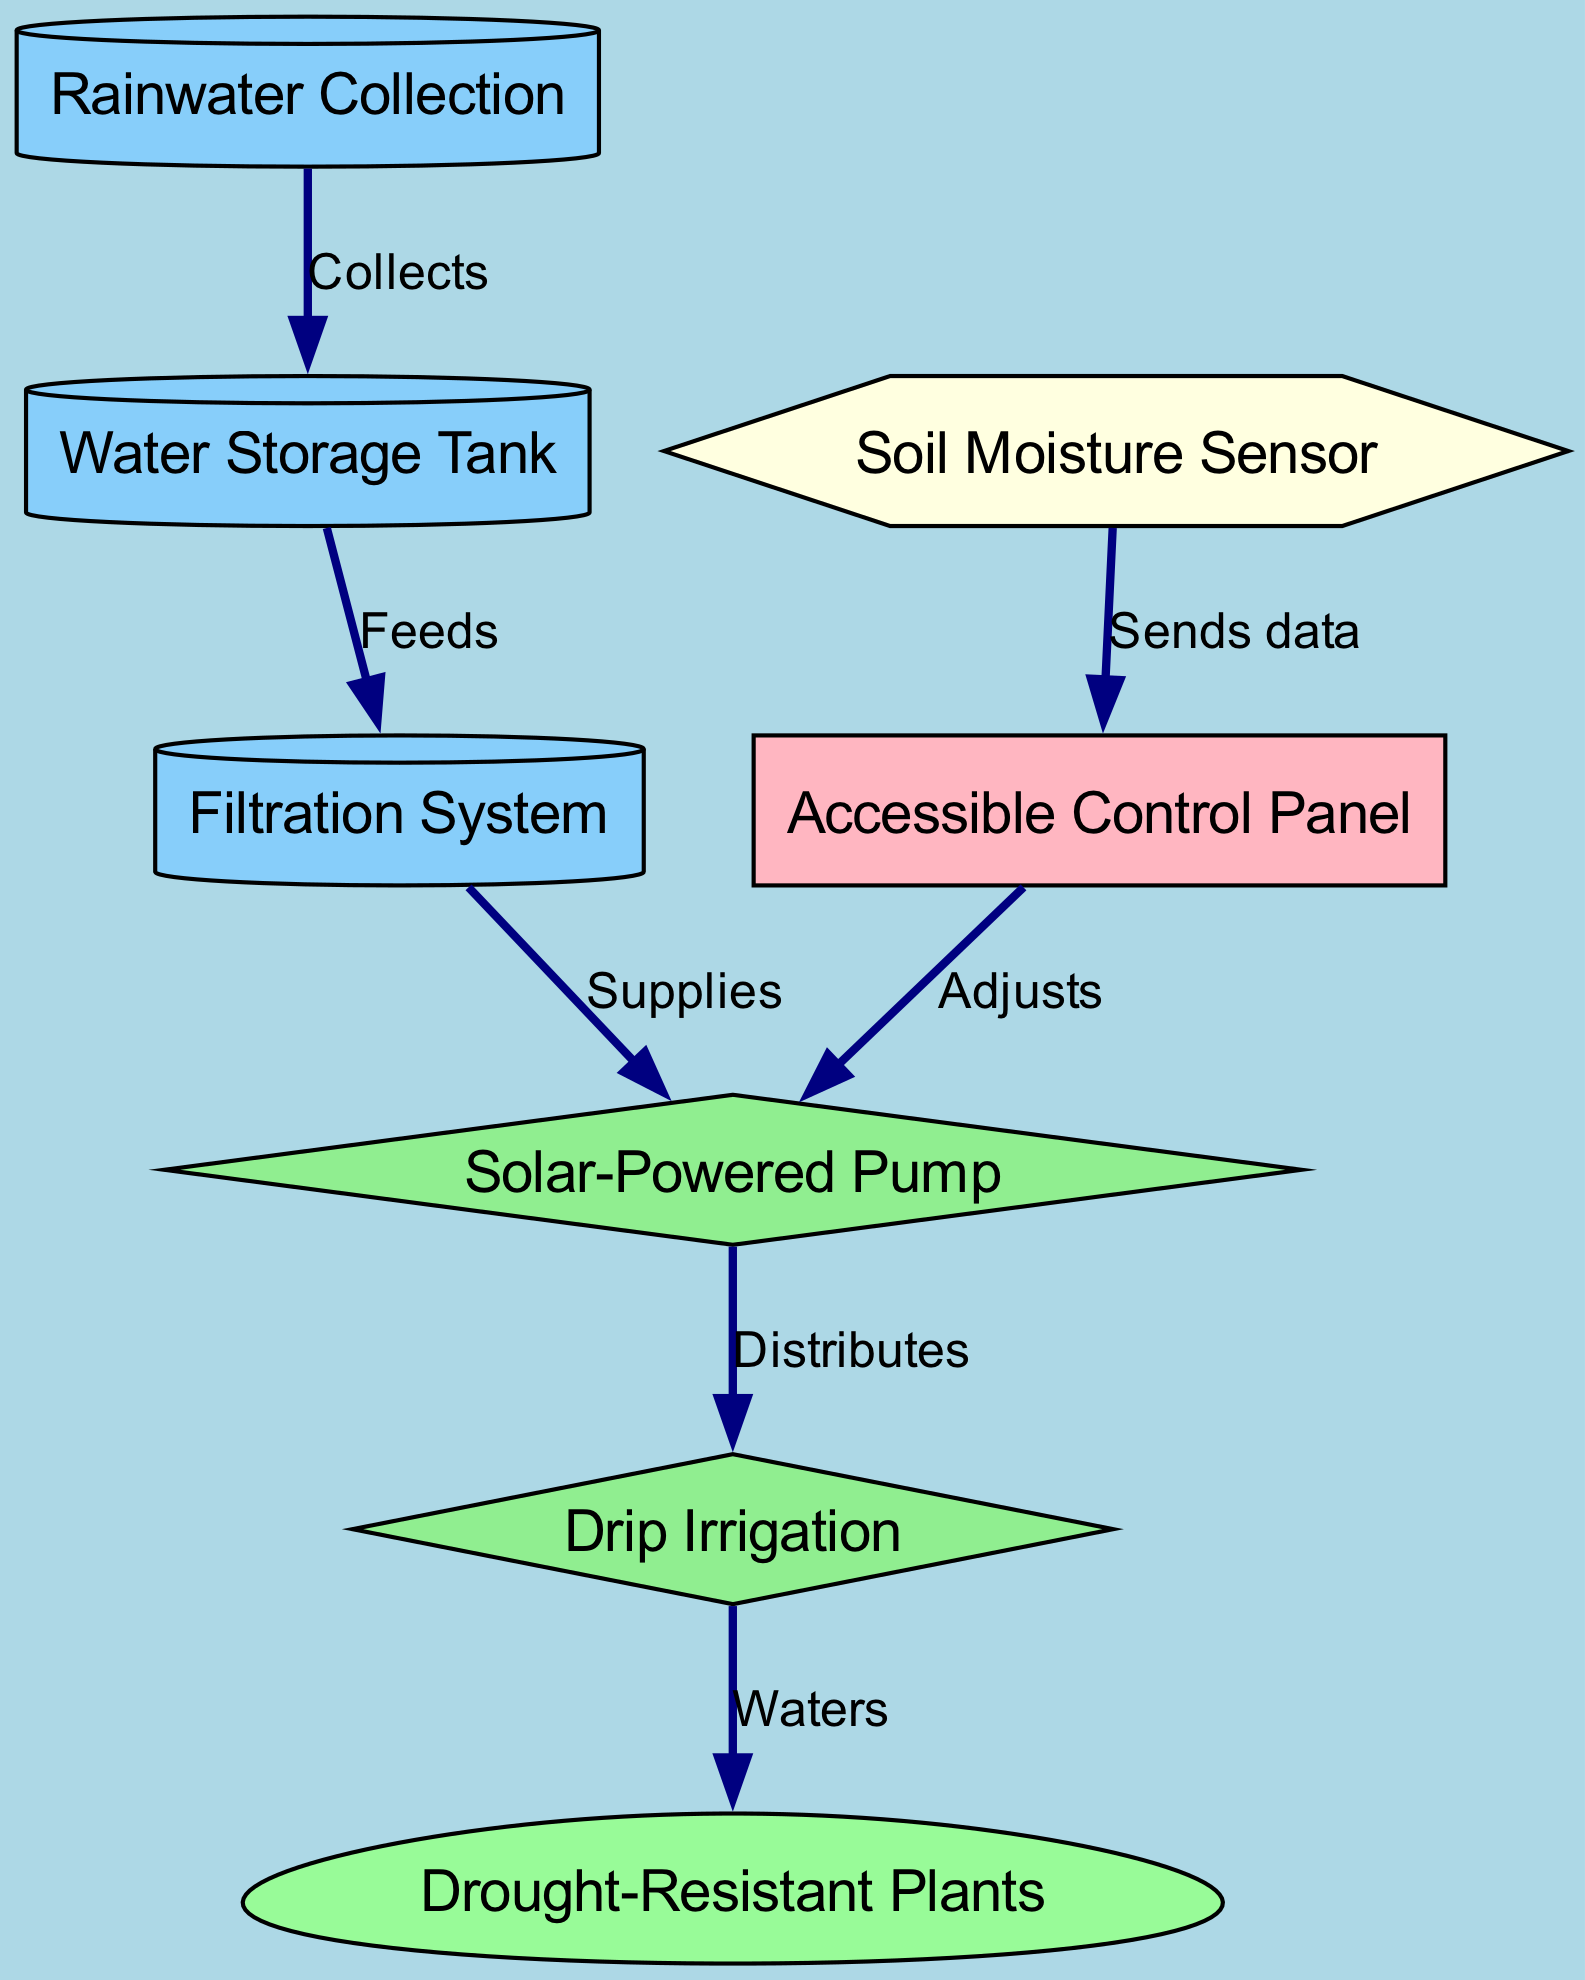What is the first step in the water cycle for the garden? The first step represented in the diagram is "Rainwater Collection," which shows the initial gathering of rainwater before any further processes occur.
Answer: Rainwater Collection How many nodes are present in the diagram? The diagram includes 8 distinct nodes that represent various components of the water cycle and irrigation system.
Answer: 8 Which system supplies water from the filtration to the pump? The edge labeled "Supplies" indicates that the "Filtration System" is the node responsible for supplying water to the "Solar-Powered Pump."
Answer: Filtration System What does the soil moisture sensor communicate with? The diagram shows that the "Soil Moisture Sensor" sends data to the "Accessible Control Panel," indicating its role in monitoring soil conditions.
Answer: Accessible Control Panel Which node receives water from the drip irrigation system? The diagram indicates that "Drip Irrigation" is connected to the node labeled "Drought-Resistant Plants," showing where the water ends up.
Answer: Drought-Resistant Plants What controls the adjustment of the solar-powered pump based on moisture levels? The diagram shows that the "Accessible Control Panel" adjusts the "Solar-Powered Pump," based on the data it receives, ensuring proper irrigation control.
Answer: Accessible Control Panel What type of irrigation method is used in the garden? According to the diagram, the irrigation method described is "Drip Irrigation," which is a precise watering technique connected to the plant section.
Answer: Drip Irrigation How does water flow from the storage to the filtration system? The flow is represented as "Feeds," which connects the "Water Storage Tank" to the "Filtration System," indicating the direction of water transfer.
Answer: Feeds 